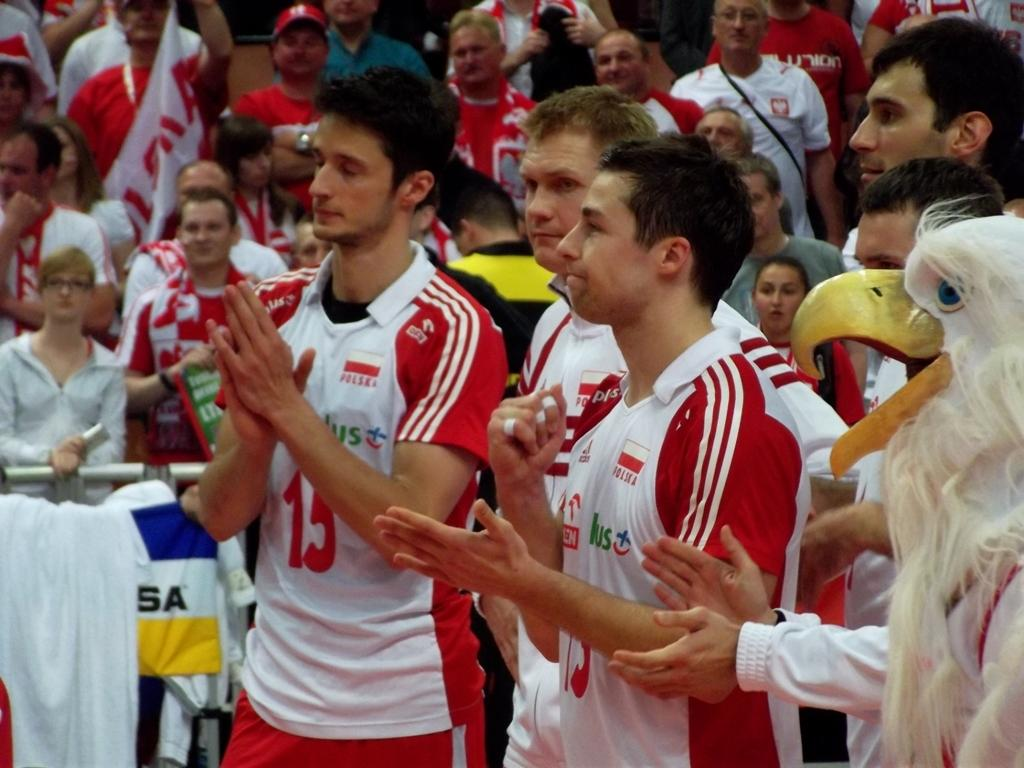Provide a one-sentence caption for the provided image. Polish athletes stand next to each other along with an eagle mascot. 